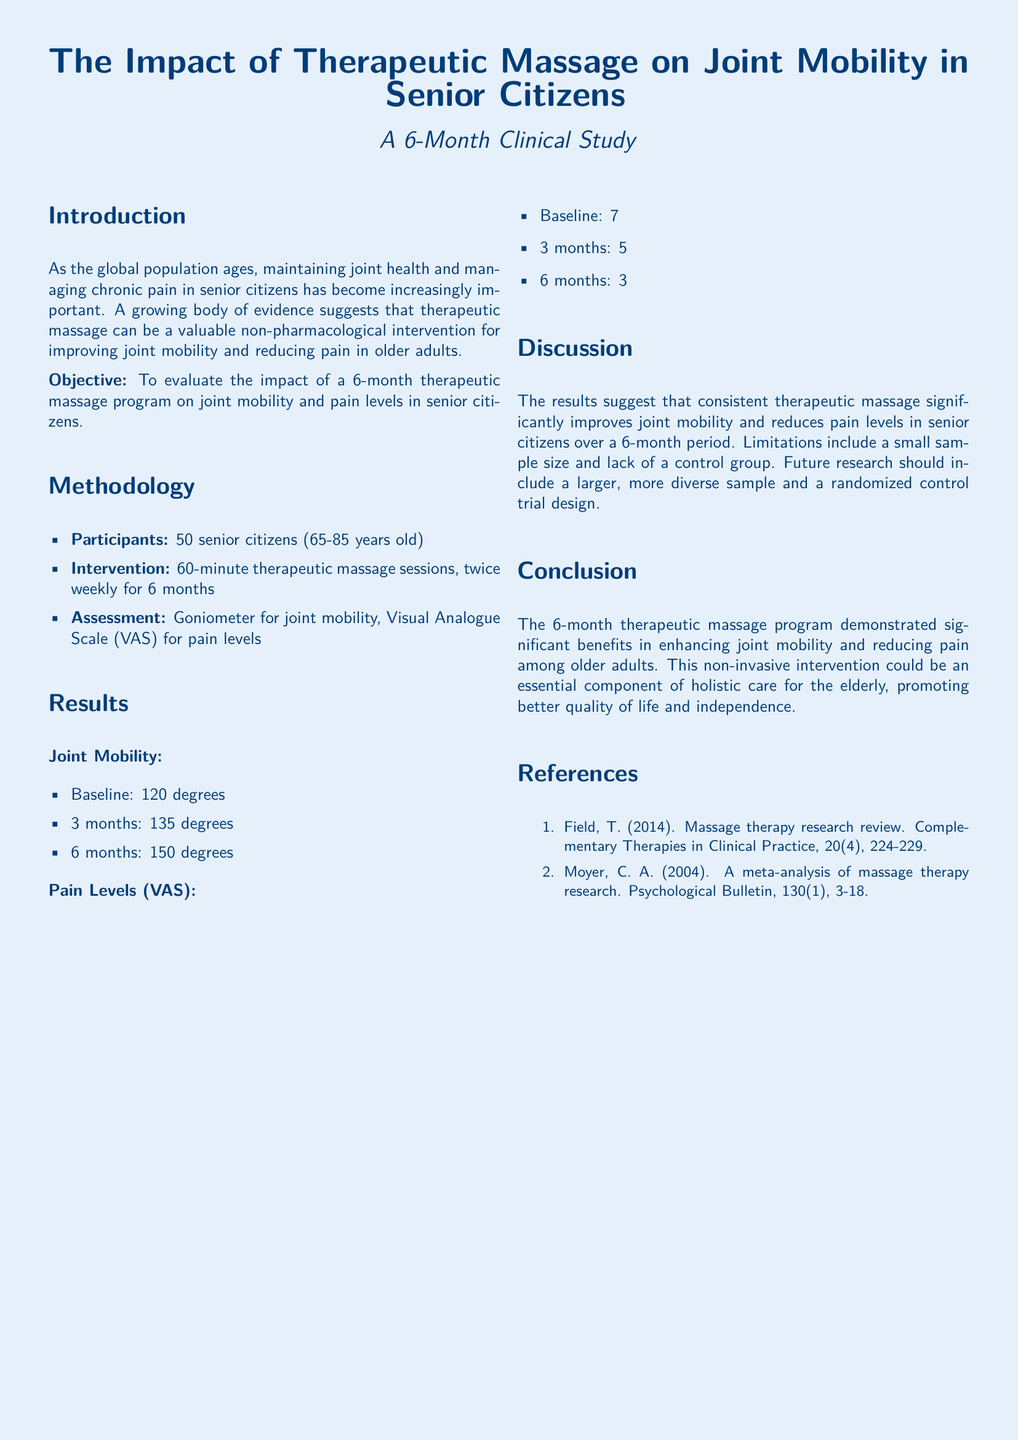What is the age range of participants? The age range of participants in the study is provided in the methodology section, specifying that participants are between 65 and 85 years old.
Answer: 65-85 years old How many therapeutic massage sessions were conducted weekly? The methodology section states the frequency of the therapeutic massage sessions performed during the study.
Answer: Twice weekly What was the baseline joint mobility measurement? The results section provides the baseline joint mobility measurement taken at the beginning of the study.
Answer: 120 degrees What was the pain level on the Visual Analogue Scale at 3 months? The results section lists the pain levels at different time points, including the value at the 3-month mark.
Answer: 5 What are the implications of the study's findings? The discussion section indicates the significance of the results, highlighting the benefits of massage on joint mobility and pain management in seniors.
Answer: Significant benefits What is one limitation mentioned in the study? The discussion section outlines limitations faced during the study, including the sample size and control group issues.
Answer: Small sample size What was the duration of the therapeutic massage program? The introduction section states the time frame of the therapeutic massage program implemented in the study.
Answer: 6 months How was joint mobility assessed in the study? The methodology states that joint mobility was assessed with a specific tool, detailing the approach taken to measure joint flexibility.
Answer: Goniometer 